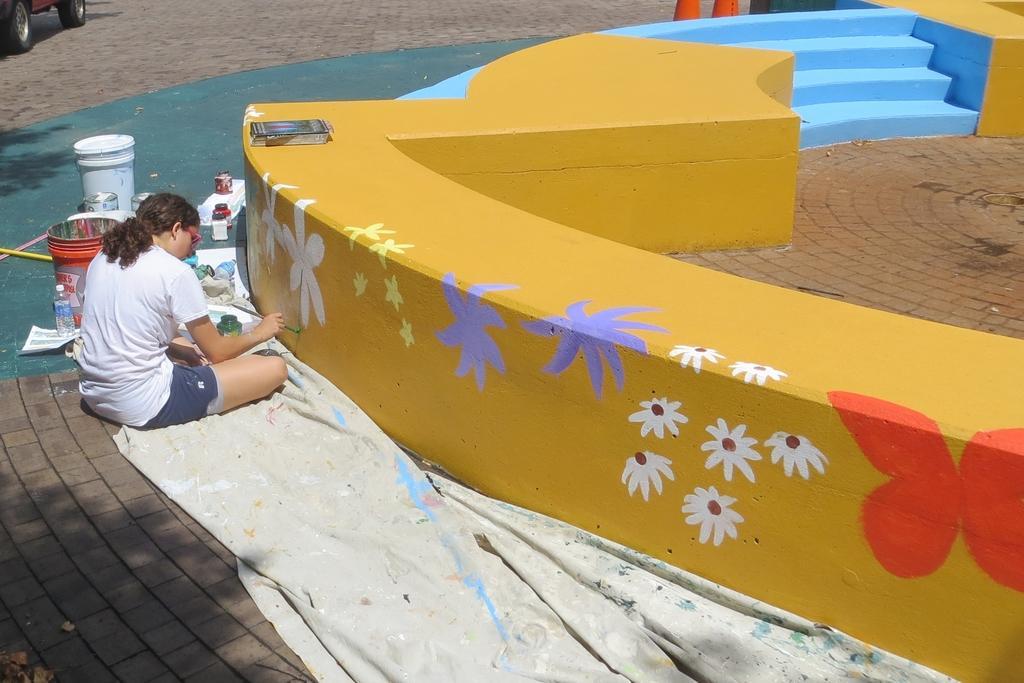Could you give a brief overview of what you see in this image? In this picture we can see a person sitting and painting on the wall. We can see an object on the wall. There are a few buckets, bottles and a white cloth is visible on the path. We can see a vehicle on the top left and a few dry leaves in the bottom left. 